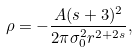Convert formula to latex. <formula><loc_0><loc_0><loc_500><loc_500>\rho = - \frac { A ( s + 3 ) ^ { 2 } } { 2 \pi \sigma _ { 0 } ^ { 2 } r ^ { 2 + 2 s } } ,</formula> 